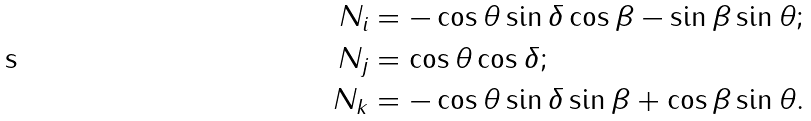<formula> <loc_0><loc_0><loc_500><loc_500>N _ { i } & = - \cos \theta \sin \delta \cos \beta - \sin \beta \sin \theta ; \\ N _ { j } & = \cos \theta \cos \delta ; \\ N _ { k } & = - \cos \theta \sin \delta \sin \beta + \cos \beta \sin \theta .</formula> 